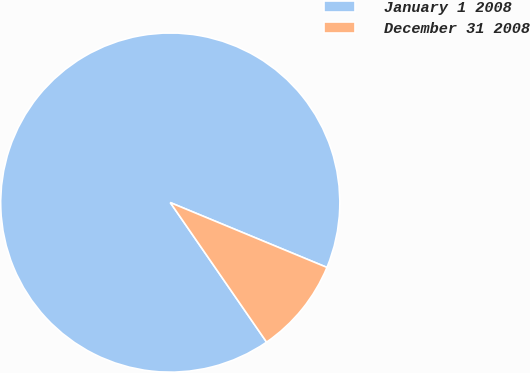Convert chart to OTSL. <chart><loc_0><loc_0><loc_500><loc_500><pie_chart><fcel>January 1 2008<fcel>December 31 2008<nl><fcel>90.86%<fcel>9.14%<nl></chart> 